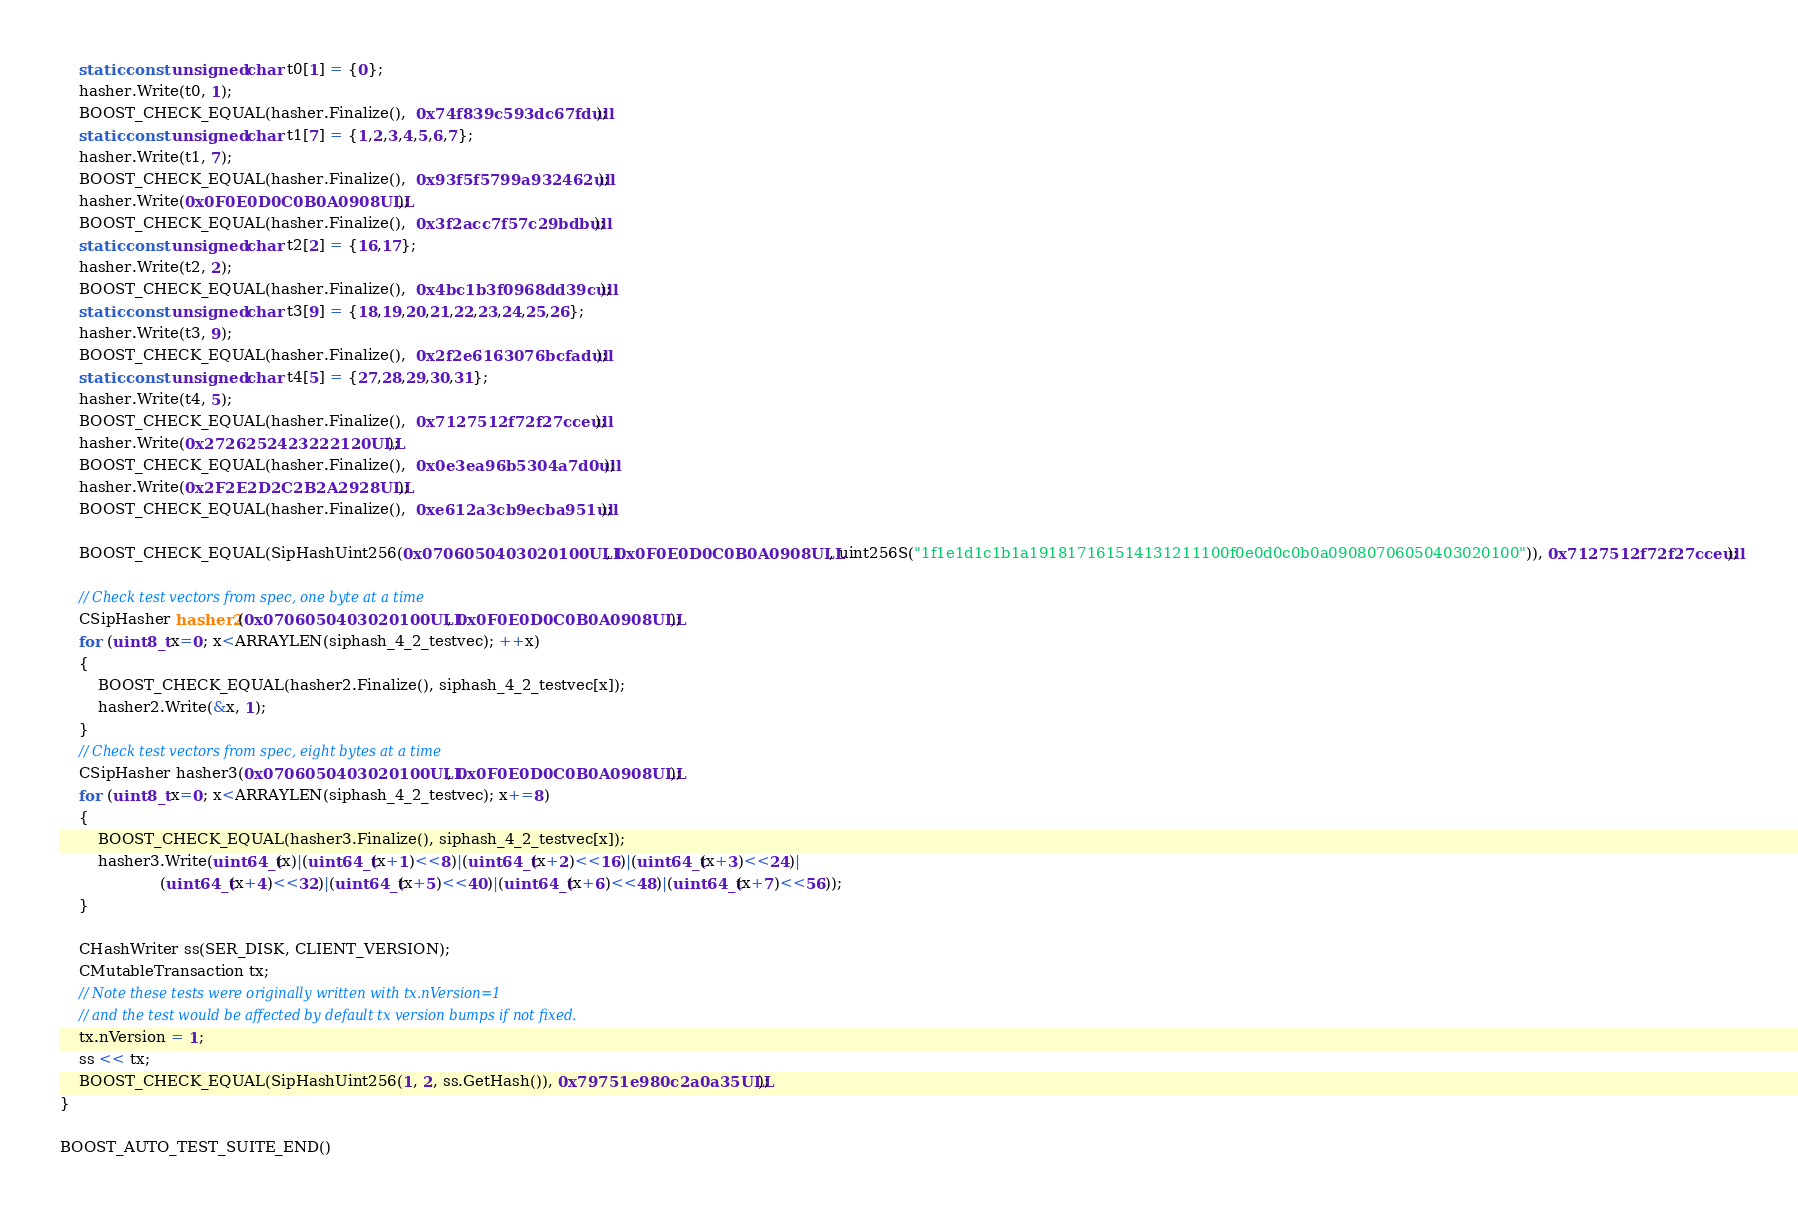Convert code to text. <code><loc_0><loc_0><loc_500><loc_500><_C++_>    static const unsigned char t0[1] = {0};
    hasher.Write(t0, 1);
    BOOST_CHECK_EQUAL(hasher.Finalize(),  0x74f839c593dc67fdull);
    static const unsigned char t1[7] = {1,2,3,4,5,6,7};
    hasher.Write(t1, 7);
    BOOST_CHECK_EQUAL(hasher.Finalize(),  0x93f5f5799a932462ull);
    hasher.Write(0x0F0E0D0C0B0A0908ULL);
    BOOST_CHECK_EQUAL(hasher.Finalize(),  0x3f2acc7f57c29bdbull);
    static const unsigned char t2[2] = {16,17};
    hasher.Write(t2, 2);
    BOOST_CHECK_EQUAL(hasher.Finalize(),  0x4bc1b3f0968dd39cull);
    static const unsigned char t3[9] = {18,19,20,21,22,23,24,25,26};
    hasher.Write(t3, 9);
    BOOST_CHECK_EQUAL(hasher.Finalize(),  0x2f2e6163076bcfadull);
    static const unsigned char t4[5] = {27,28,29,30,31};
    hasher.Write(t4, 5);
    BOOST_CHECK_EQUAL(hasher.Finalize(),  0x7127512f72f27cceull);
    hasher.Write(0x2726252423222120ULL);
    BOOST_CHECK_EQUAL(hasher.Finalize(),  0x0e3ea96b5304a7d0ull);
    hasher.Write(0x2F2E2D2C2B2A2928ULL);
    BOOST_CHECK_EQUAL(hasher.Finalize(),  0xe612a3cb9ecba951ull);

    BOOST_CHECK_EQUAL(SipHashUint256(0x0706050403020100ULL, 0x0F0E0D0C0B0A0908ULL, uint256S("1f1e1d1c1b1a191817161514131211100f0e0d0c0b0a09080706050403020100")), 0x7127512f72f27cceull);

    // Check test vectors from spec, one byte at a time
    CSipHasher hasher2(0x0706050403020100ULL, 0x0F0E0D0C0B0A0908ULL);
    for (uint8_t x=0; x<ARRAYLEN(siphash_4_2_testvec); ++x)
    {
        BOOST_CHECK_EQUAL(hasher2.Finalize(), siphash_4_2_testvec[x]);
        hasher2.Write(&x, 1);
    }
    // Check test vectors from spec, eight bytes at a time
    CSipHasher hasher3(0x0706050403020100ULL, 0x0F0E0D0C0B0A0908ULL);
    for (uint8_t x=0; x<ARRAYLEN(siphash_4_2_testvec); x+=8)
    {
        BOOST_CHECK_EQUAL(hasher3.Finalize(), siphash_4_2_testvec[x]);
        hasher3.Write(uint64_t(x)|(uint64_t(x+1)<<8)|(uint64_t(x+2)<<16)|(uint64_t(x+3)<<24)|
                     (uint64_t(x+4)<<32)|(uint64_t(x+5)<<40)|(uint64_t(x+6)<<48)|(uint64_t(x+7)<<56));
    }

    CHashWriter ss(SER_DISK, CLIENT_VERSION);
    CMutableTransaction tx;
    // Note these tests were originally written with tx.nVersion=1
    // and the test would be affected by default tx version bumps if not fixed.
    tx.nVersion = 1;
    ss << tx;
    BOOST_CHECK_EQUAL(SipHashUint256(1, 2, ss.GetHash()), 0x79751e980c2a0a35ULL);
}

BOOST_AUTO_TEST_SUITE_END()
</code> 